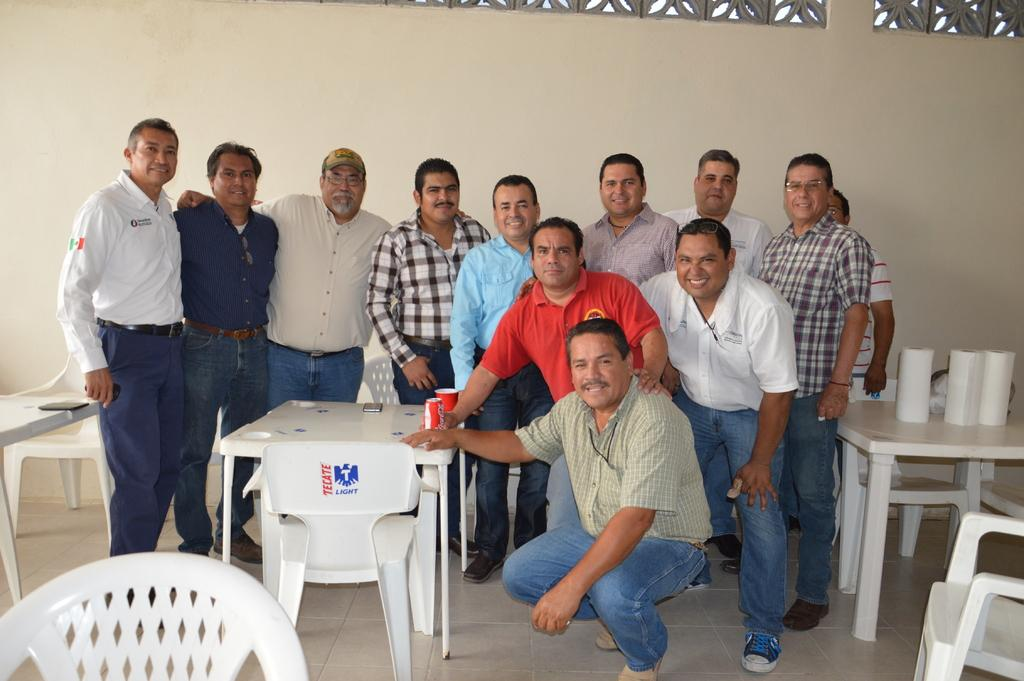How many people are in the image? There is a group of persons standing in the image. What type of furniture is present in the image? There are tables and chairs in the image. What objects can be seen on the tables? There are mobiles, a tin, a cup, and a paper roll on the tables. How many bears are visible in the image? There are no bears present in the image. What fact can be learned about the tin from the image? The image does not provide any specific facts about the tin; it only shows that there is a tin on the table. 